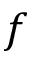Convert formula to latex. <formula><loc_0><loc_0><loc_500><loc_500>f</formula> 